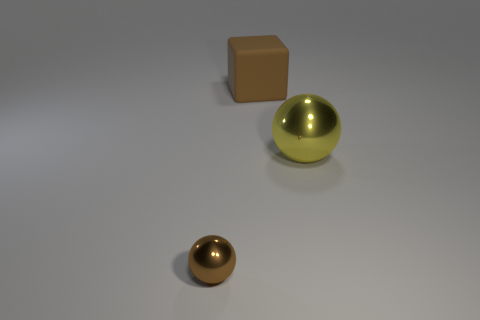There is a object in front of the large metallic thing; is its color the same as the object right of the large brown rubber object? no 